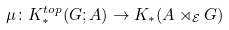Convert formula to latex. <formula><loc_0><loc_0><loc_500><loc_500>\mu \colon K _ { * } ^ { t o p } ( G ; A ) \to K _ { * } ( A \rtimes _ { \mathcal { E } } G )</formula> 